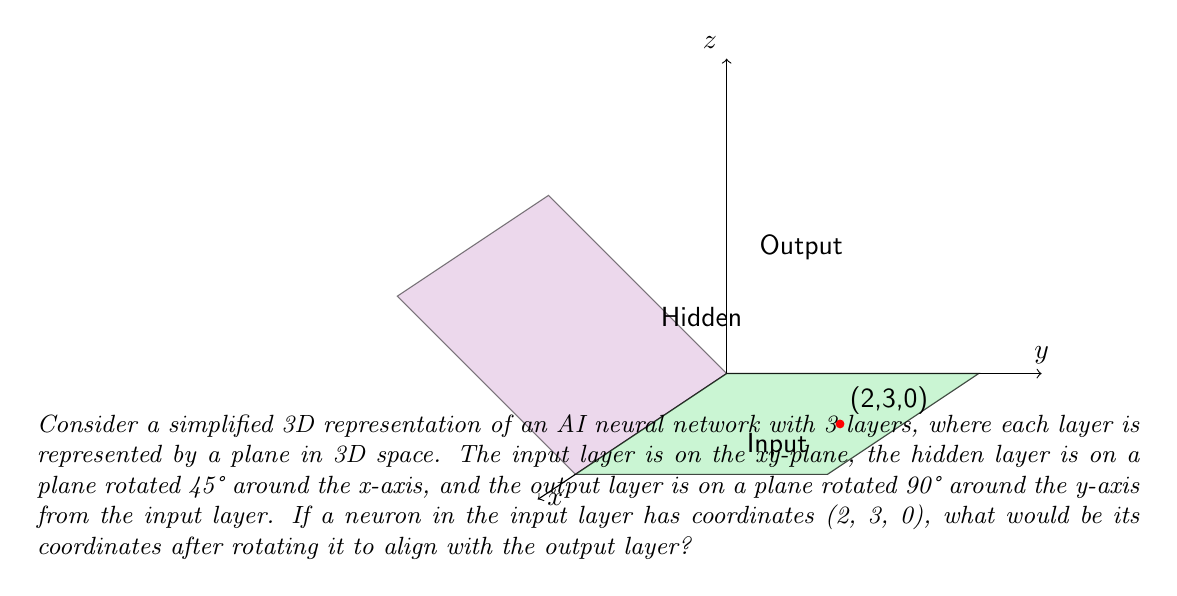Solve this math problem. To solve this problem, we need to apply a rotation transformation to the given point. The rotation is 90° around the y-axis, which can be represented by the following rotation matrix:

$$R_y(90°) = \begin{pmatrix}
\cos 90° & 0 & \sin 90° \\
0 & 1 & 0 \\
-\sin 90° & 0 & \cos 90°
\end{pmatrix} = \begin{pmatrix}
0 & 0 & 1 \\
0 & 1 & 0 \\
-1 & 0 & 0
\end{pmatrix}$$

Let's apply this rotation to the point (2, 3, 0):

$$\begin{pmatrix}
0 & 0 & 1 \\
0 & 1 & 0 \\
-1 & 0 & 0
\end{pmatrix} \begin{pmatrix}
2 \\
3 \\
0
\end{pmatrix} = \begin{pmatrix}
0 \cdot 2 + 0 \cdot 3 + 1 \cdot 0 \\
0 \cdot 2 + 1 \cdot 3 + 0 \cdot 0 \\
-1 \cdot 2 + 0 \cdot 3 + 0 \cdot 0
\end{pmatrix} = \begin{pmatrix}
0 \\
3 \\
-2
\end{pmatrix}$$

Therefore, after rotation, the point (2, 3, 0) becomes (0, 3, -2).
Answer: (0, 3, -2) 